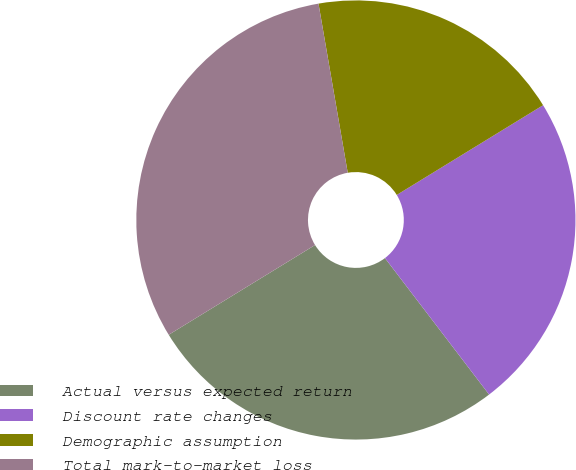<chart> <loc_0><loc_0><loc_500><loc_500><pie_chart><fcel>Actual versus expected return<fcel>Discount rate changes<fcel>Demographic assumption<fcel>Total mark-to-market loss<nl><fcel>26.62%<fcel>23.38%<fcel>18.97%<fcel>31.03%<nl></chart> 